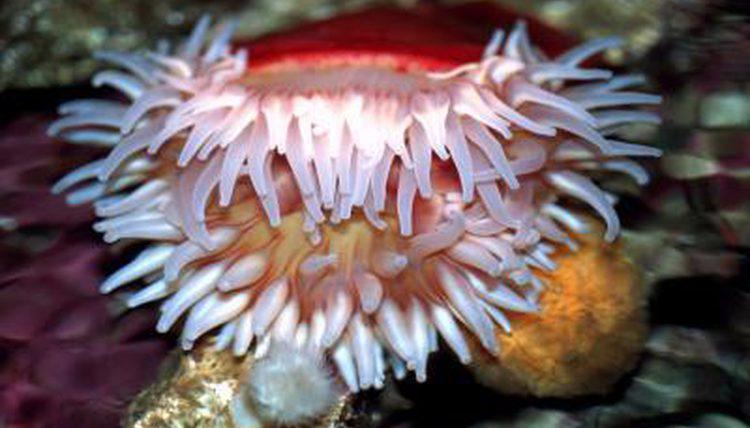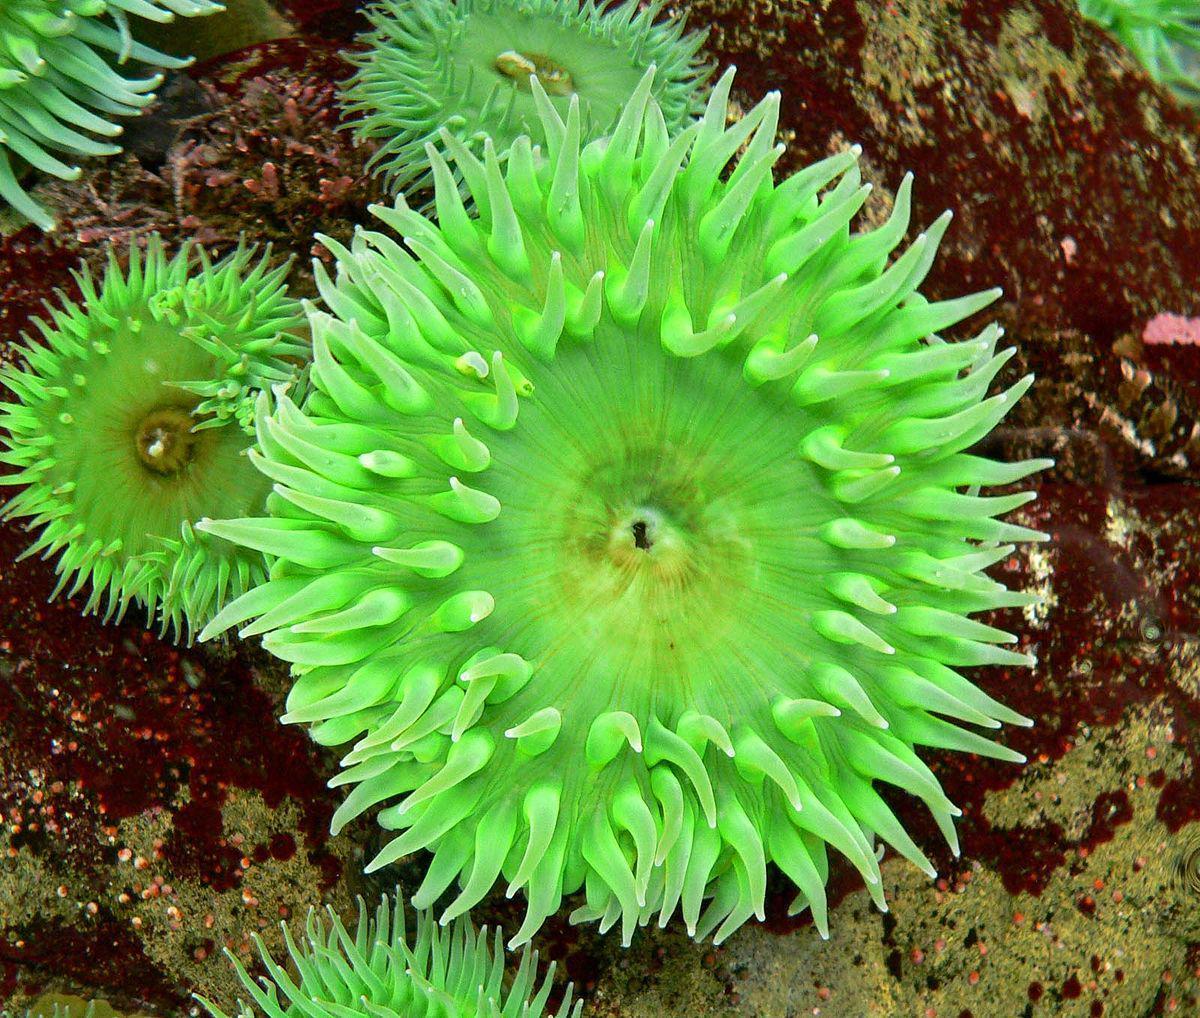The first image is the image on the left, the second image is the image on the right. Assess this claim about the two images: "Right image features at least one anemone with a green tint.". Correct or not? Answer yes or no. Yes. The first image is the image on the left, the second image is the image on the right. Given the left and right images, does the statement "There are at least two anemones in one of the images." hold true? Answer yes or no. Yes. 